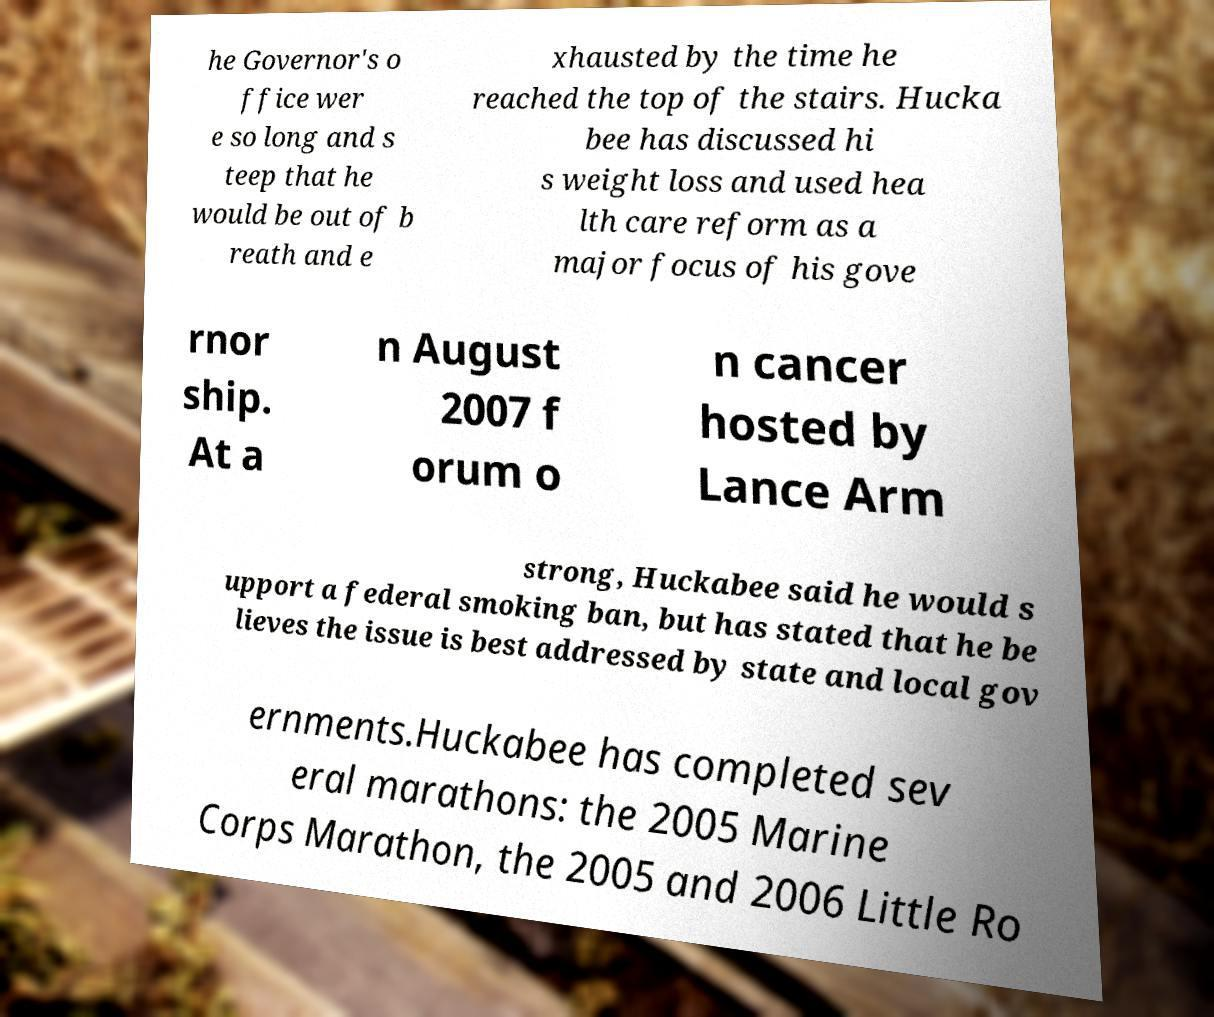Please identify and transcribe the text found in this image. he Governor's o ffice wer e so long and s teep that he would be out of b reath and e xhausted by the time he reached the top of the stairs. Hucka bee has discussed hi s weight loss and used hea lth care reform as a major focus of his gove rnor ship. At a n August 2007 f orum o n cancer hosted by Lance Arm strong, Huckabee said he would s upport a federal smoking ban, but has stated that he be lieves the issue is best addressed by state and local gov ernments.Huckabee has completed sev eral marathons: the 2005 Marine Corps Marathon, the 2005 and 2006 Little Ro 